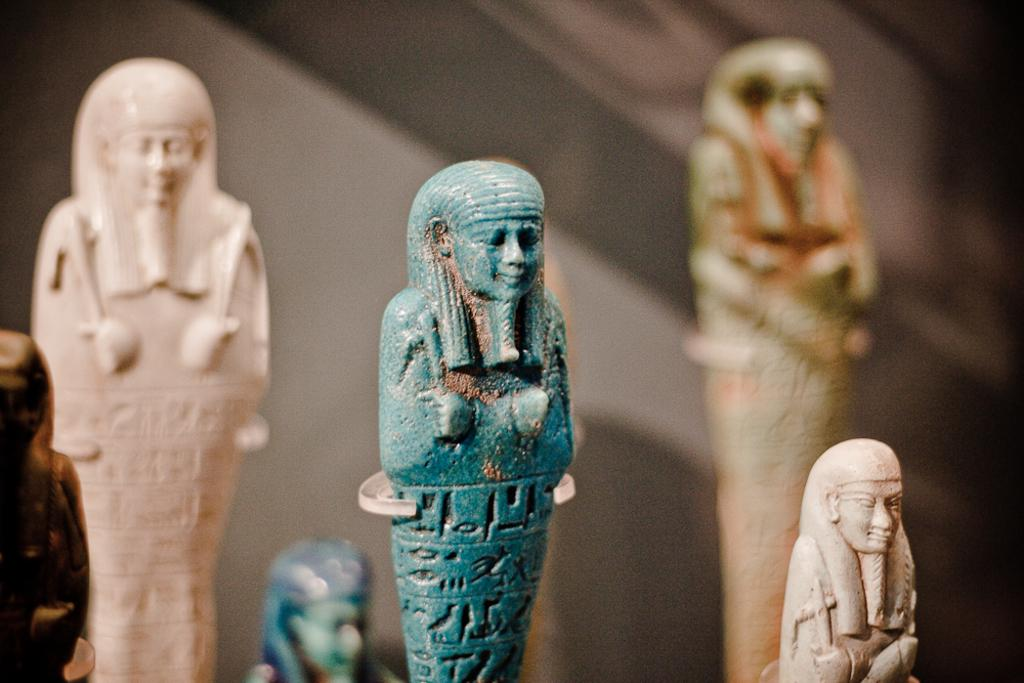What can be seen in the image? There are statues in the image. What is visible in the background of the image? There is a wall in the background of the image. What type of jelly is being served to the visitor in the image? There is no jelly or visitor present in the image; it only features statues and a wall in the background. 